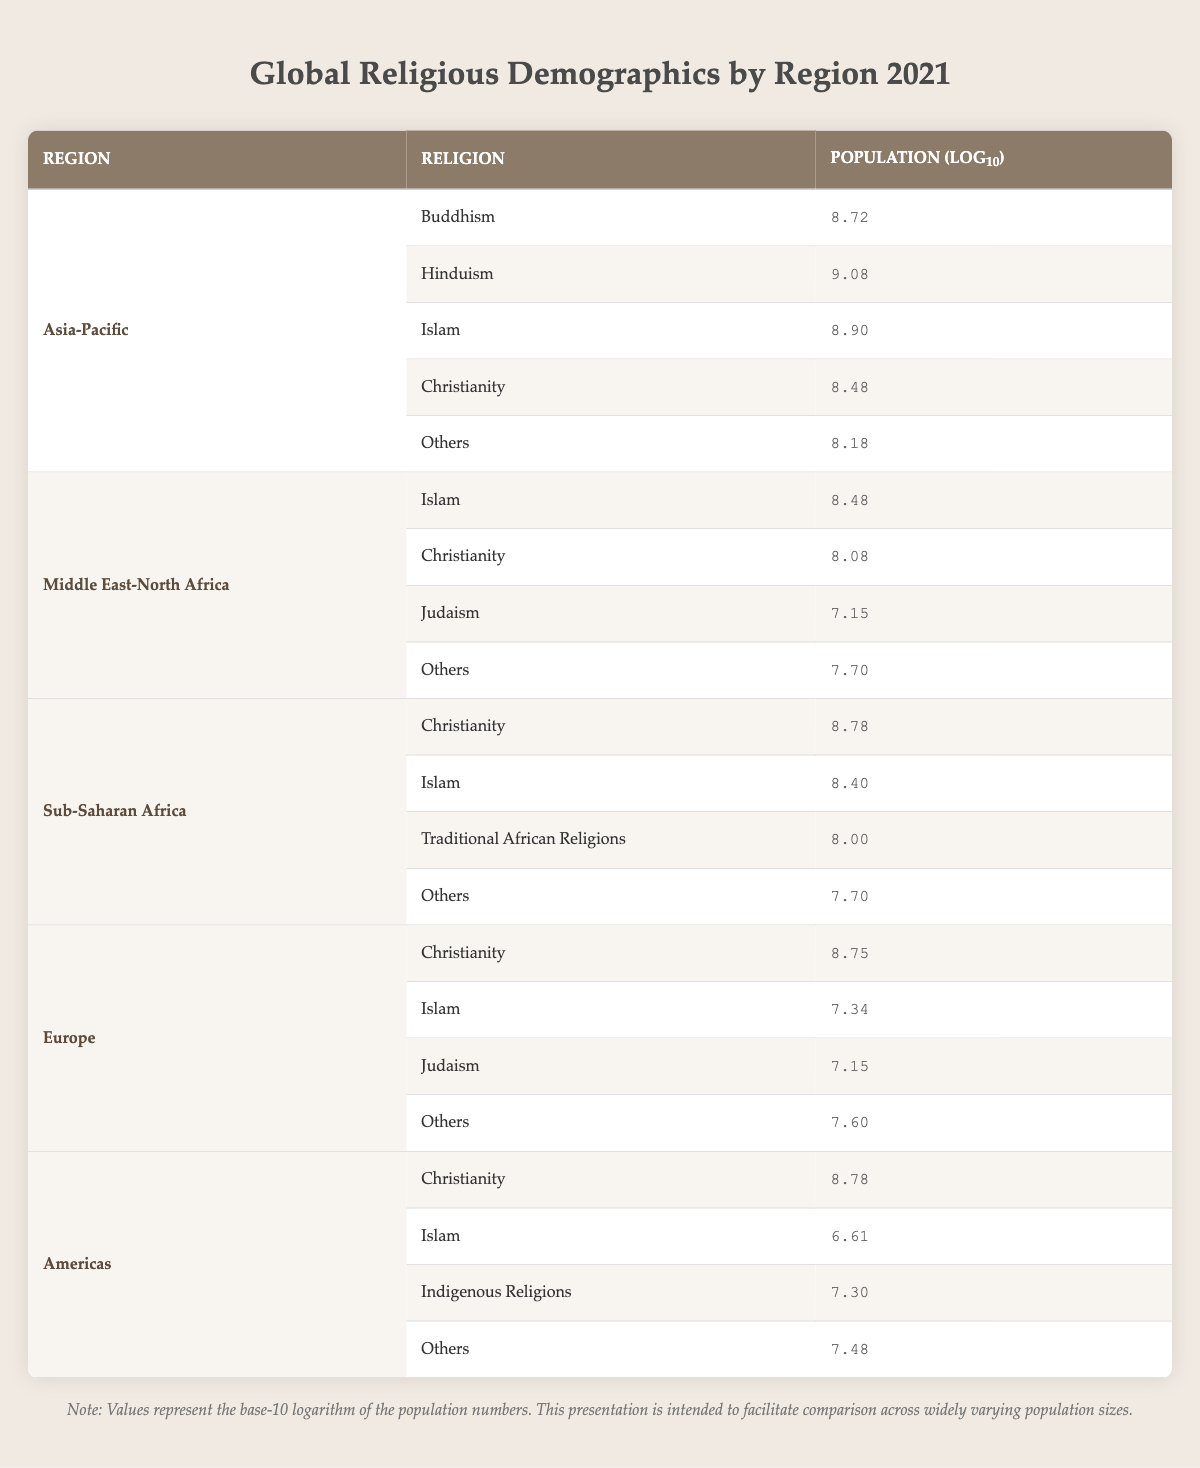What is the population (log10) of Buddhism in the Asia-Pacific region? The table specifies the population of Buddhism in the Asia-Pacific region as 520,000,000. The corresponding log10 value for this population is provided in the table as 8.72.
Answer: 8.72 Which religion has the largest logarithmic population value in Sub-Saharan Africa? In Sub-Saharan Africa, the table lists the logarithmic population values of various religions. The highest value is for Christianity at 8.78, showing it has the largest logarithmic population in this region.
Answer: Christianity What is the combined logarithmic value of the populations of Islam in the Asia-Pacific and the Middle East-North Africa regions? First, we find the log10 values for Islam in both regions: in Asia-Pacific, it is 8.90; in the Middle East-North Africa, it is 8.48. We then sum these values: 8.90 + 8.48 = 17.38.
Answer: 17.38 Does Europe have a larger Islamic population (in logarithmic terms) than Judaism? In Europe, the table shows the log10 values as 7.34 for Islam and 7.15 for Judaism. Since 7.34 is greater than 7.15, it is true that Europe has a larger Islamic population than Jewish population in logarithmic terms.
Answer: Yes What is the difference in logarithmic values between Christianity in the Americas and Christianity in the Middle East-North Africa? The log10 value for Christianity in the Americas is 8.78. For the Middle East-North Africa, it is 8.08. The difference is calculated as 8.78 - 8.08 = 0.70.
Answer: 0.70 What is the average logarithmic population value of all the religions listed in the Middle East-North Africa region? The log10 values for religions in this region are 8.48 (Islam), 8.08 (Christianity), 7.15 (Judaism), and 7.70 (Others). We sum these values: 8.48 + 8.08 + 7.15 + 7.70 = 31.41. There are four religions, so we divide by 4: 31.41 / 4 = 7.85.
Answer: 7.85 Which region has the highest log10 value for Others? In the provided table, we see the log10 values for "Others" as follows: Asia-Pacific 8.18, Middle East-North Africa 7.70, Sub-Saharan Africa 7.70, Europe 7.60, and the Americas 7.48. The highest value is 8.18 from the Asia-Pacific region.
Answer: Asia-Pacific What is the total population (log10) of Christianity across all regions? The log10 values for Christianity in each region are as follows: Asia-Pacific 8.48, Middle East-North Africa 8.08, Sub-Saharan Africa 8.78, Europe 8.75, and Americas 8.78. Summing these gives: 8.48 + 8.08 + 8.78 + 8.75 + 8.78 = 43.17.
Answer: 43.17 